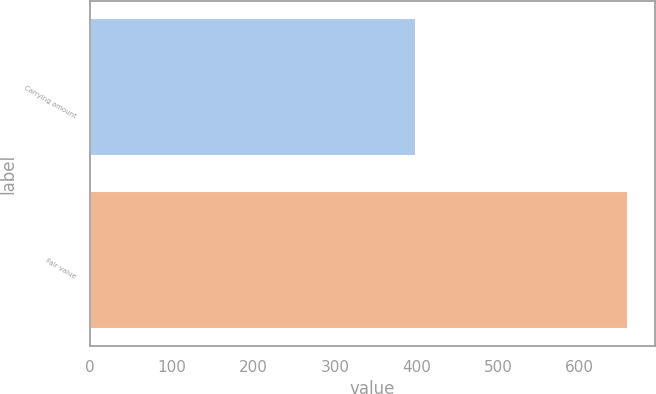Convert chart. <chart><loc_0><loc_0><loc_500><loc_500><bar_chart><fcel>Carrying amount<fcel>Fair value<nl><fcel>399.5<fcel>659.2<nl></chart> 